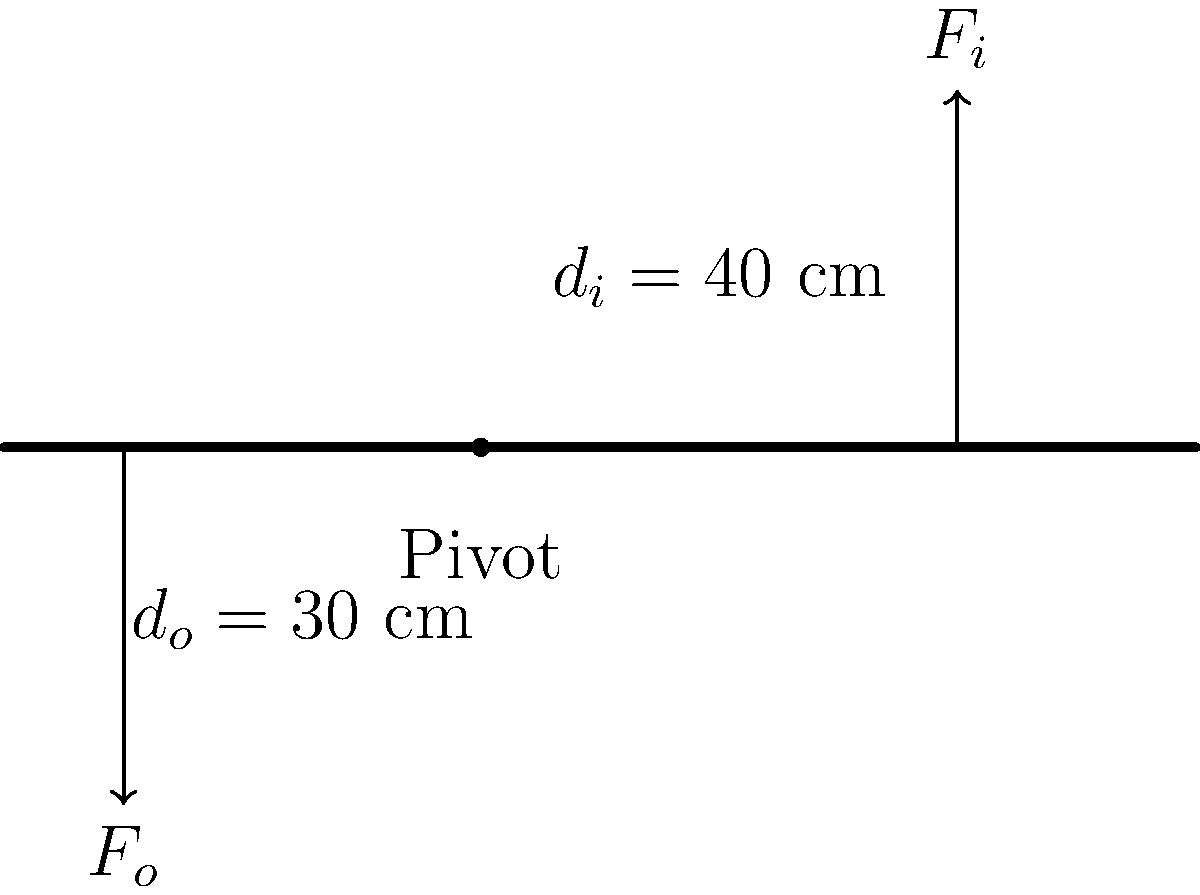In the lever mechanism of a hand tool shown above, an input force $F_i$ is applied at a distance of 40 cm from the pivot point, while the output force $F_o$ acts at a distance of 30 cm from the pivot on the opposite side. If the input force is 50 N, what is the magnitude of the output force $F_o$ when the system is in equilibrium? To solve this problem, we'll use the principle of moments for a lever in equilibrium:

1) The sum of moments about the pivot point should be zero for equilibrium.

2) Moment = Force × perpendicular distance from the pivot

3) Let's write the equation:
   $F_i \times d_i = F_o \times d_o$

4) We know:
   $F_i = 50$ N
   $d_i = 40$ cm
   $d_o = 30$ cm

5) Substituting these values:
   $50 \text{ N} \times 40 \text{ cm} = F_o \times 30 \text{ cm}$

6) Simplify:
   $2000 \text{ N⋅cm} = 30F_o \text{ cm}$

7) Divide both sides by 30 cm:
   $\frac{2000 \text{ N⋅cm}}{30 \text{ cm}} = F_o$

8) Calculate:
   $F_o = 66.67 \text{ N}$

Therefore, the output force $F_o$ is approximately 66.67 N.
Answer: 66.67 N 